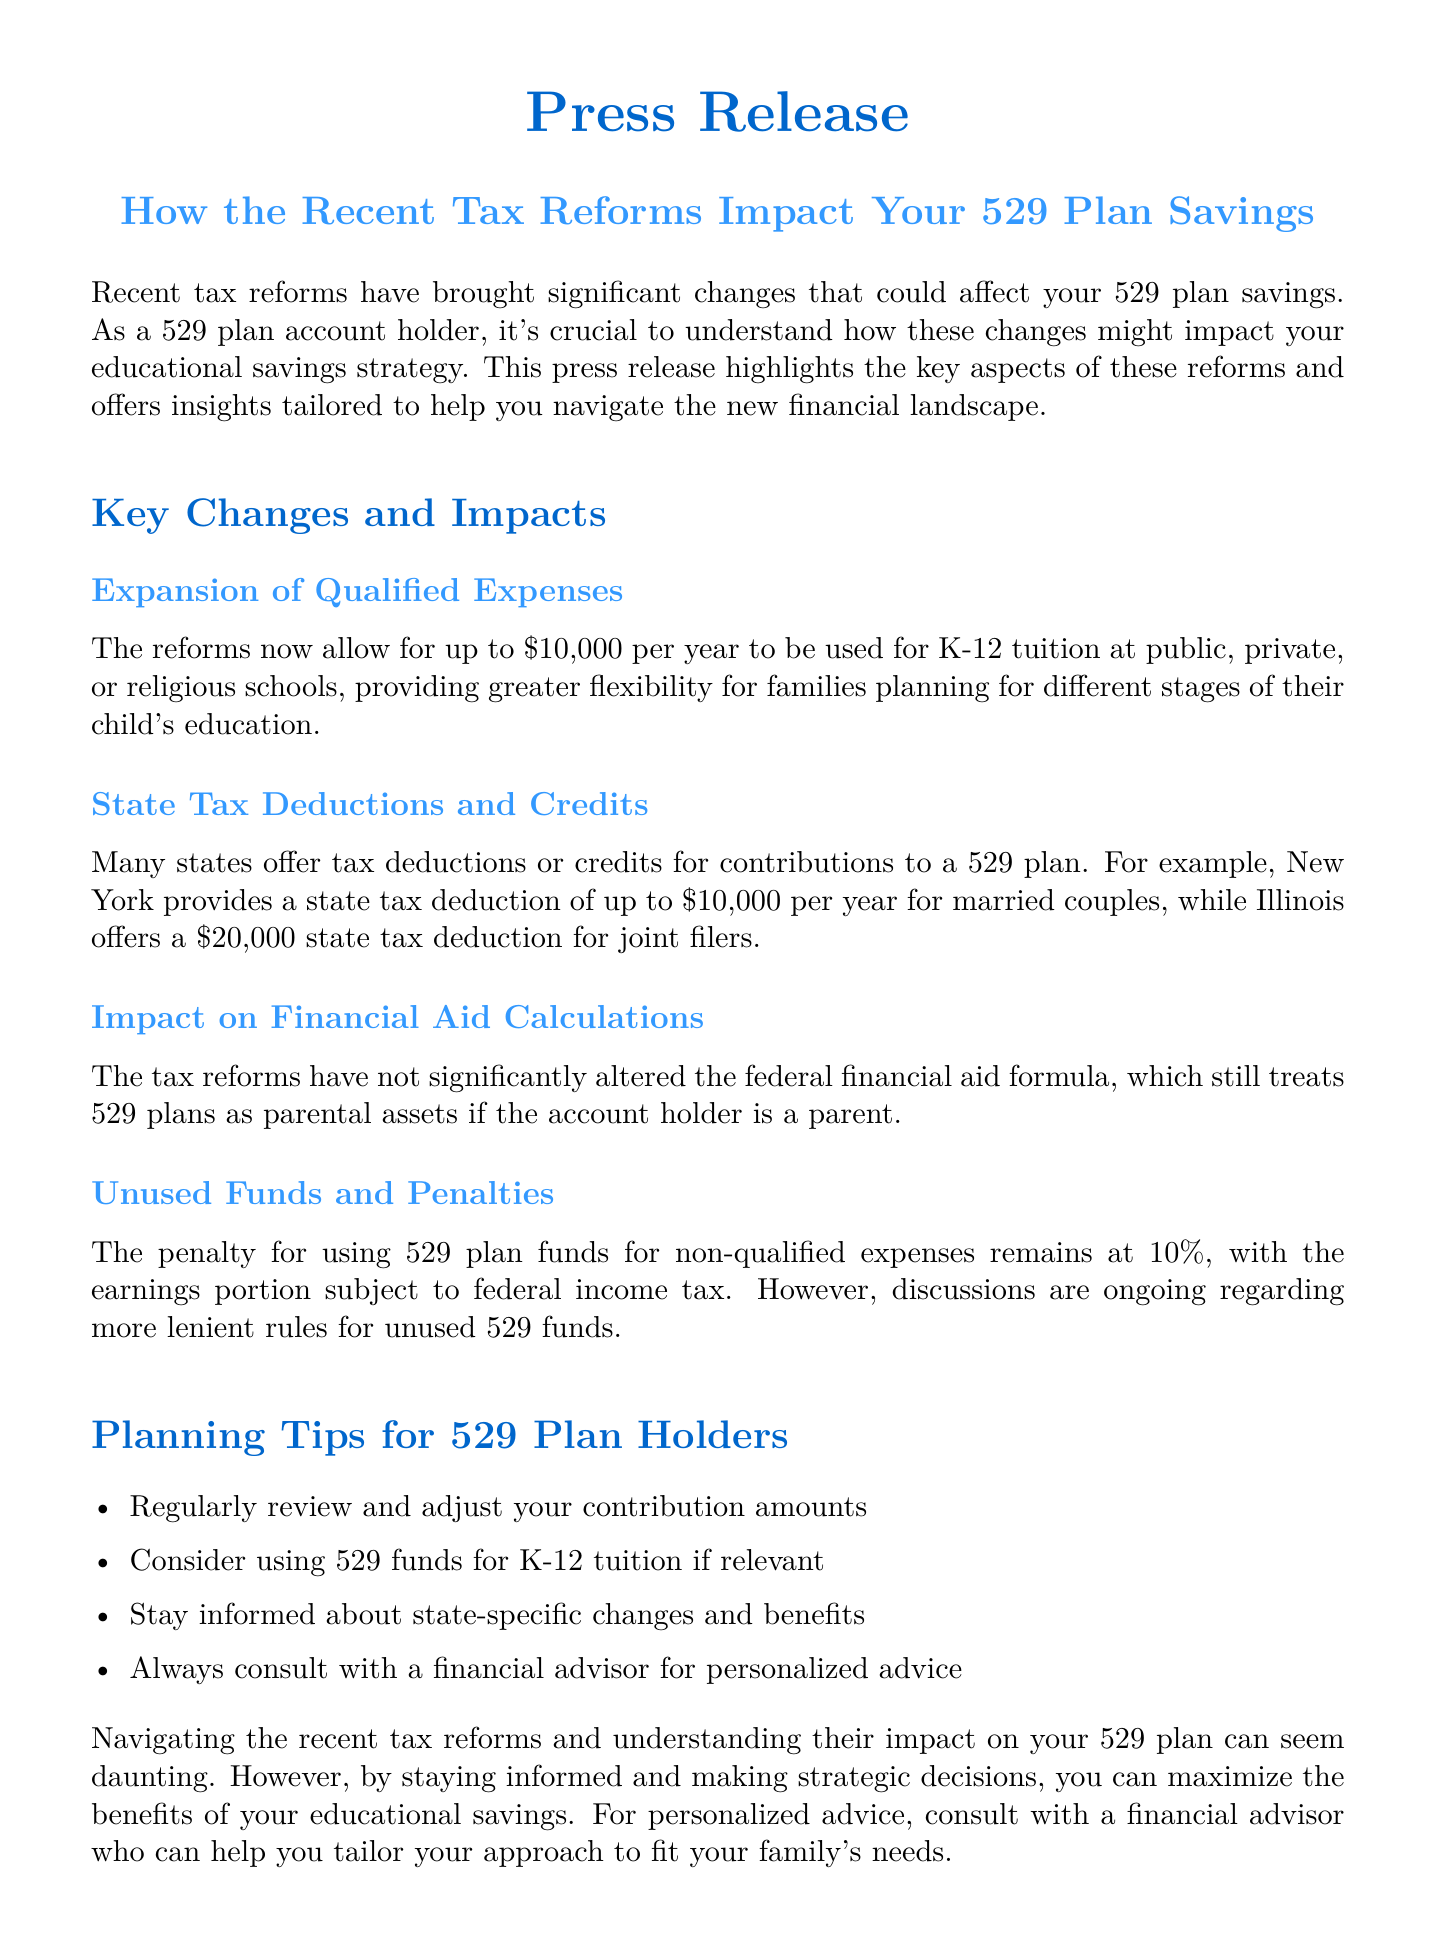What is the maximum amount that can be used for K-12 tuition? The document states that up to $10,000 per year can be used for K-12 tuition.
Answer: $10,000 Which state's 529 plan offers a tax deduction of up to $10,000 for married couples? The document mentions that New York provides a state tax deduction of up to $10,000 per year for married couples.
Answer: New York What is the penalty for using 529 plan funds for non-qualified expenses? According to the document, the penalty for using 529 plan funds for non-qualified expenses remains at 10%.
Answer: 10% What should account holders do regularly regarding their contributions? The document advises to regularly review and adjust your contribution amounts.
Answer: Review and adjust How does the tax reform impact financial aid calculations? The press release indicates that the tax reforms have not significantly altered the federal financial aid formula.
Answer: No significant change What is a recommended action for 529 plan holders to consider? The document recommends considering using 529 funds for K-12 tuition if relevant.
Answer: Use funds for K-12 tuition What is the primary focus of this press release? The document focuses on how recent tax reforms impact 529 plan savings for account holders.
Answer: Tax reforms impact What type of advice is recommended for personalized financial strategies? The document suggests consulting with a financial advisor for personalized advice.
Answer: Financial advisor 